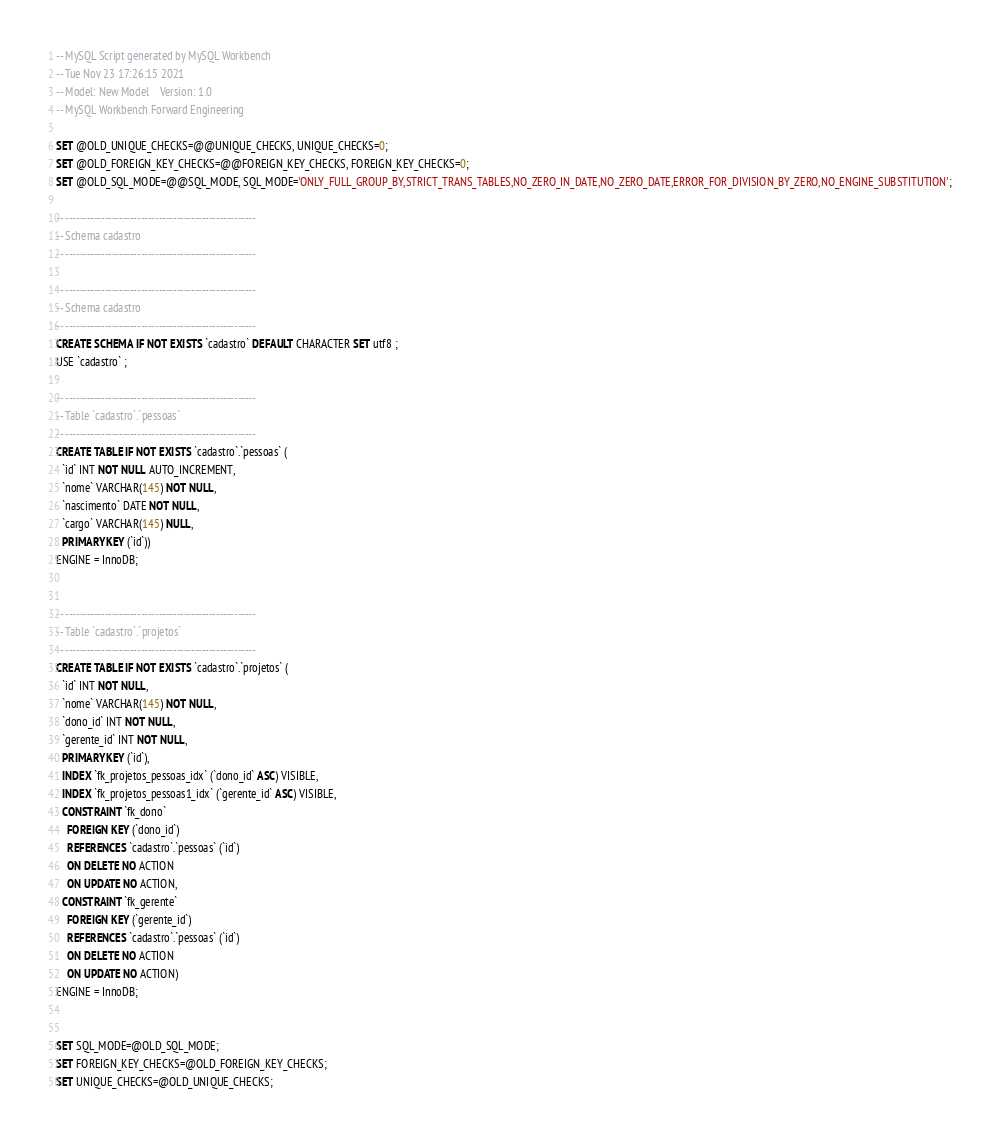<code> <loc_0><loc_0><loc_500><loc_500><_SQL_>-- MySQL Script generated by MySQL Workbench
-- Tue Nov 23 17:26:15 2021
-- Model: New Model    Version: 1.0
-- MySQL Workbench Forward Engineering

SET @OLD_UNIQUE_CHECKS=@@UNIQUE_CHECKS, UNIQUE_CHECKS=0;
SET @OLD_FOREIGN_KEY_CHECKS=@@FOREIGN_KEY_CHECKS, FOREIGN_KEY_CHECKS=0;
SET @OLD_SQL_MODE=@@SQL_MODE, SQL_MODE='ONLY_FULL_GROUP_BY,STRICT_TRANS_TABLES,NO_ZERO_IN_DATE,NO_ZERO_DATE,ERROR_FOR_DIVISION_BY_ZERO,NO_ENGINE_SUBSTITUTION';

-- -----------------------------------------------------
-- Schema cadastro
-- -----------------------------------------------------

-- -----------------------------------------------------
-- Schema cadastro
-- -----------------------------------------------------
CREATE SCHEMA IF NOT EXISTS `cadastro` DEFAULT CHARACTER SET utf8 ;
USE `cadastro` ;

-- -----------------------------------------------------
-- Table `cadastro`.`pessoas`
-- -----------------------------------------------------
CREATE TABLE IF NOT EXISTS `cadastro`.`pessoas` (
  `id` INT NOT NULL AUTO_INCREMENT,
  `nome` VARCHAR(145) NOT NULL,
  `nascimento` DATE NOT NULL,
  `cargo` VARCHAR(145) NULL,
  PRIMARY KEY (`id`))
ENGINE = InnoDB;


-- -----------------------------------------------------
-- Table `cadastro`.`projetos`
-- -----------------------------------------------------
CREATE TABLE IF NOT EXISTS `cadastro`.`projetos` (
  `id` INT NOT NULL,
  `nome` VARCHAR(145) NOT NULL,
  `dono_id` INT NOT NULL,
  `gerente_id` INT NOT NULL,
  PRIMARY KEY (`id`),
  INDEX `fk_projetos_pessoas_idx` (`dono_id` ASC) VISIBLE,
  INDEX `fk_projetos_pessoas1_idx` (`gerente_id` ASC) VISIBLE,
  CONSTRAINT `fk_dono`
    FOREIGN KEY (`dono_id`)
    REFERENCES `cadastro`.`pessoas` (`id`)
    ON DELETE NO ACTION
    ON UPDATE NO ACTION,
  CONSTRAINT `fk_gerente`
    FOREIGN KEY (`gerente_id`)
    REFERENCES `cadastro`.`pessoas` (`id`)
    ON DELETE NO ACTION
    ON UPDATE NO ACTION)
ENGINE = InnoDB;


SET SQL_MODE=@OLD_SQL_MODE;
SET FOREIGN_KEY_CHECKS=@OLD_FOREIGN_KEY_CHECKS;
SET UNIQUE_CHECKS=@OLD_UNIQUE_CHECKS;
</code> 